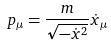<formula> <loc_0><loc_0><loc_500><loc_500>p _ { \mu } = \frac { m } { \sqrt { - \dot { x } ^ { 2 } } } \dot { x } _ { \mu }</formula> 